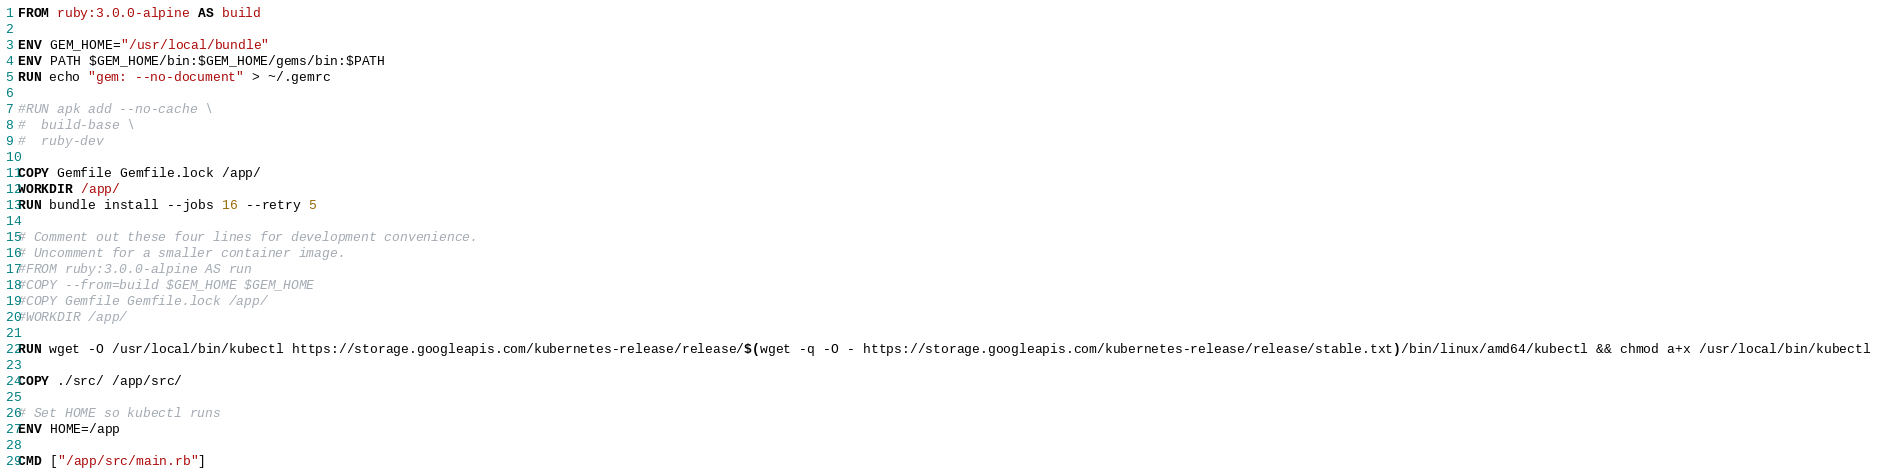<code> <loc_0><loc_0><loc_500><loc_500><_Dockerfile_>FROM ruby:3.0.0-alpine AS build

ENV GEM_HOME="/usr/local/bundle"
ENV PATH $GEM_HOME/bin:$GEM_HOME/gems/bin:$PATH
RUN echo "gem: --no-document" > ~/.gemrc

#RUN apk add --no-cache \
#  build-base \
#  ruby-dev

COPY Gemfile Gemfile.lock /app/
WORKDIR /app/
RUN bundle install --jobs 16 --retry 5

# Comment out these four lines for development convenience.
# Uncomment for a smaller container image.
#FROM ruby:3.0.0-alpine AS run
#COPY --from=build $GEM_HOME $GEM_HOME
#COPY Gemfile Gemfile.lock /app/
#WORKDIR /app/

RUN wget -O /usr/local/bin/kubectl https://storage.googleapis.com/kubernetes-release/release/$(wget -q -O - https://storage.googleapis.com/kubernetes-release/release/stable.txt)/bin/linux/amd64/kubectl && chmod a+x /usr/local/bin/kubectl

COPY ./src/ /app/src/

# Set HOME so kubectl runs
ENV HOME=/app

CMD ["/app/src/main.rb"]
</code> 